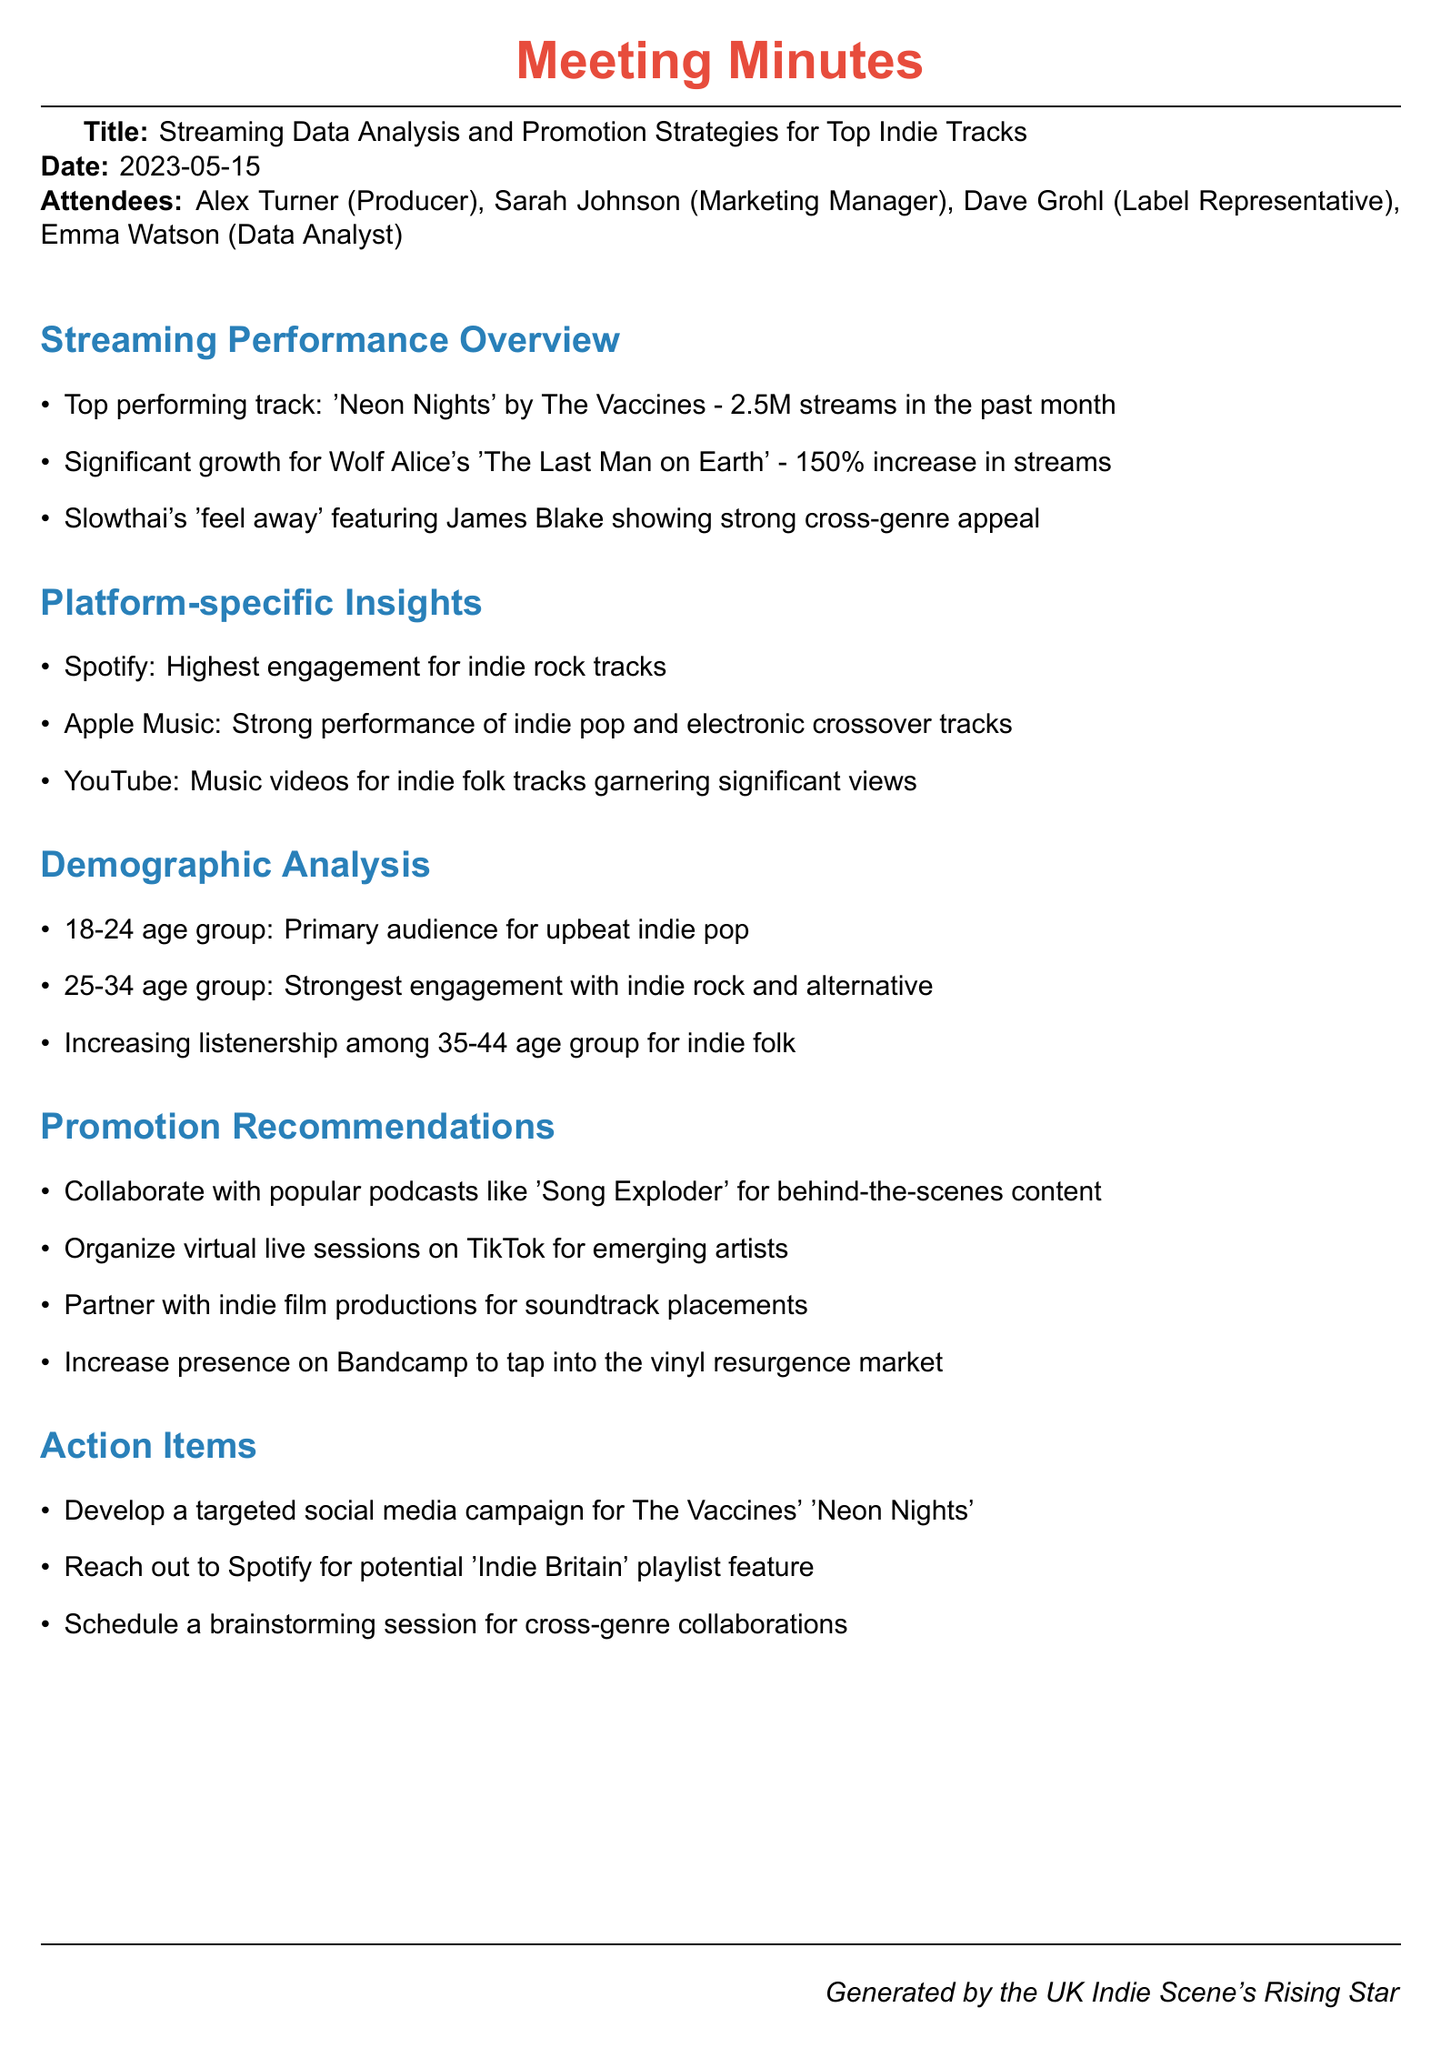What is the title of the meeting? The title of the meeting is clearly stated at the beginning of the document.
Answer: Streaming Data Analysis and Promotion Strategies for Top Indie Tracks What was the date of the meeting? The date of the meeting is mentioned right after the title.
Answer: 2023-05-15 Who is the top performing artist mentioned in the overview? The overview highlights the top performing track and artist.
Answer: The Vaccines How many streams did 'Neon Nights' receive in the past month? The number of streams for 'Neon Nights' is specifically noted in the overview section.
Answer: 2.5M streams Which platform shows the highest engagement for indie rock tracks? The platform-specific insights section identifies which platform has the highest engagement.
Answer: Spotify What demographic is the primary audience for upbeat indie pop? The demographic analysis details the primary audience for upbeat indie pop tracks.
Answer: 18-24 age group How much growth did Wolf Alice's track experience? The meeting minutes provide a specific percentage increase in streams for Wolf Alice's track.
Answer: 150% What is one of the promotion recommendations listed? The promotion recommendations section states various strategies, one of which can be cited.
Answer: Collaborate with popular podcasts like 'Song Exploder' What is one action item related to 'Neon Nights'? The action items include specific tasks regarding the promotion of 'Neon Nights'.
Answer: Develop a targeted social media campaign for The Vaccines' 'Neon Nights' 